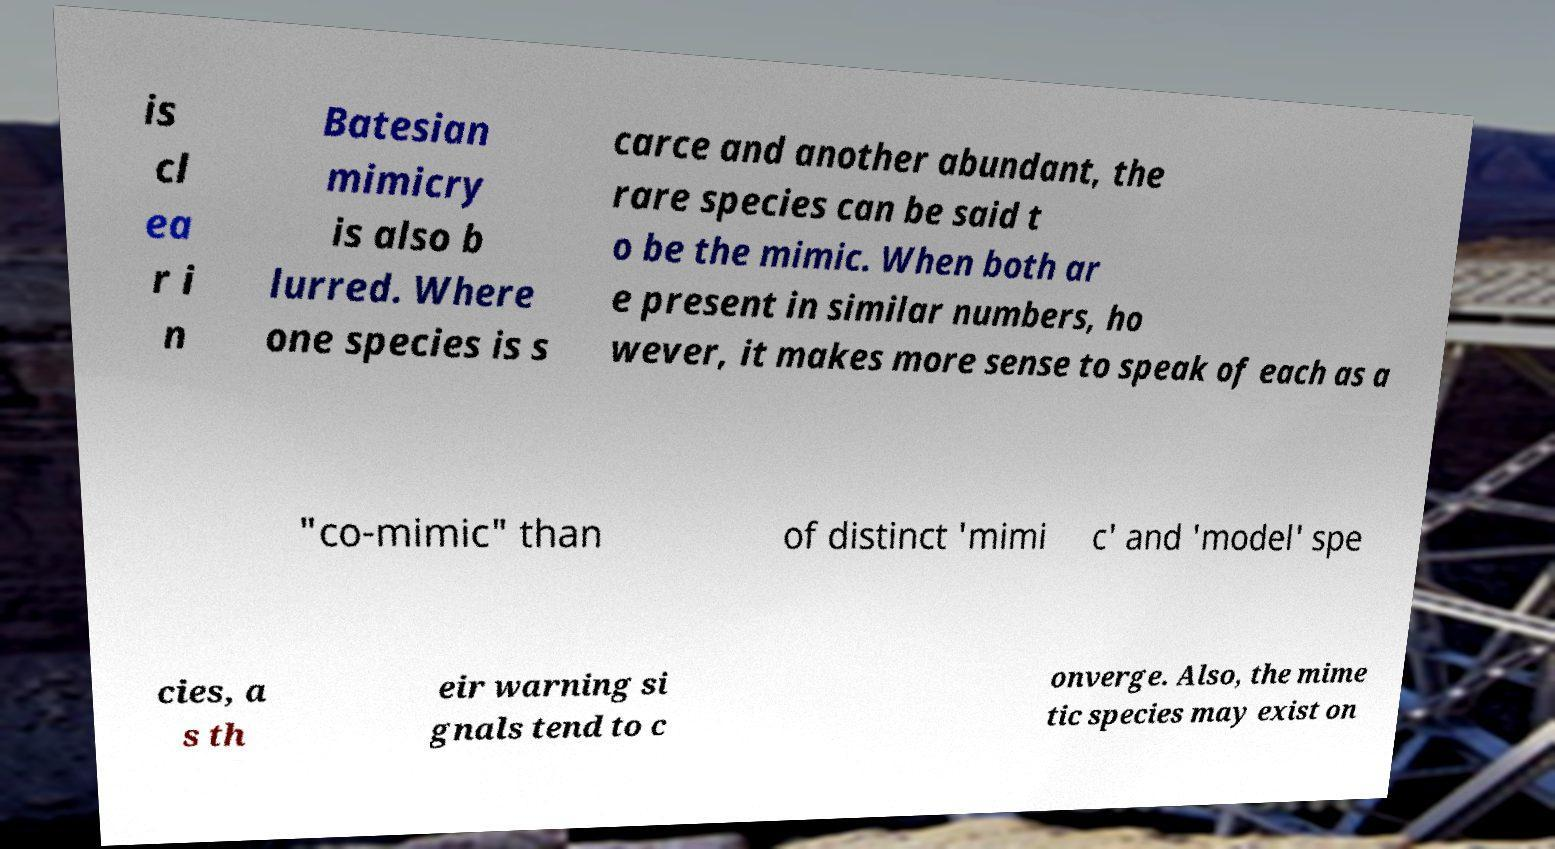What messages or text are displayed in this image? I need them in a readable, typed format. is cl ea r i n Batesian mimicry is also b lurred. Where one species is s carce and another abundant, the rare species can be said t o be the mimic. When both ar e present in similar numbers, ho wever, it makes more sense to speak of each as a "co-mimic" than of distinct 'mimi c' and 'model' spe cies, a s th eir warning si gnals tend to c onverge. Also, the mime tic species may exist on 